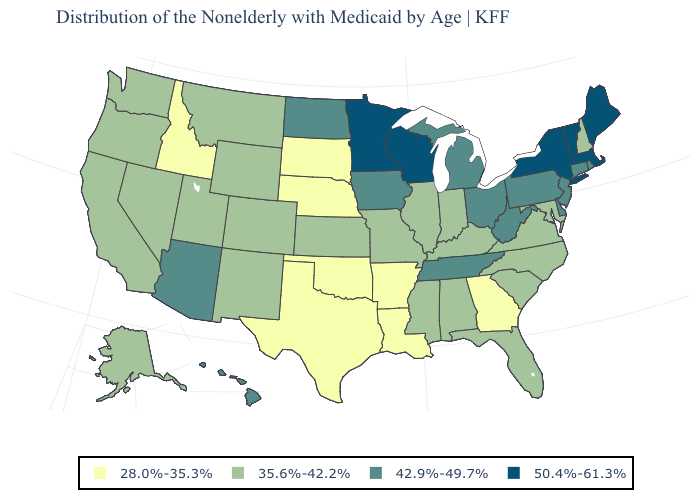What is the value of Oregon?
Be succinct. 35.6%-42.2%. What is the value of Tennessee?
Answer briefly. 42.9%-49.7%. What is the value of Nevada?
Give a very brief answer. 35.6%-42.2%. Name the states that have a value in the range 50.4%-61.3%?
Answer briefly. Maine, Massachusetts, Minnesota, New York, Vermont, Wisconsin. Does Minnesota have the highest value in the MidWest?
Quick response, please. Yes. Does Arkansas have the lowest value in the USA?
Short answer required. Yes. Does Nevada have a lower value than Florida?
Be succinct. No. Does West Virginia have the highest value in the USA?
Short answer required. No. What is the highest value in states that border Ohio?
Keep it brief. 42.9%-49.7%. What is the value of Virginia?
Be succinct. 35.6%-42.2%. Does Rhode Island have the highest value in the Northeast?
Give a very brief answer. No. How many symbols are there in the legend?
Give a very brief answer. 4. Name the states that have a value in the range 35.6%-42.2%?
Quick response, please. Alabama, Alaska, California, Colorado, Florida, Illinois, Indiana, Kansas, Kentucky, Maryland, Mississippi, Missouri, Montana, Nevada, New Hampshire, New Mexico, North Carolina, Oregon, South Carolina, Utah, Virginia, Washington, Wyoming. What is the highest value in states that border Tennessee?
Be succinct. 35.6%-42.2%. What is the highest value in the West ?
Be succinct. 42.9%-49.7%. 